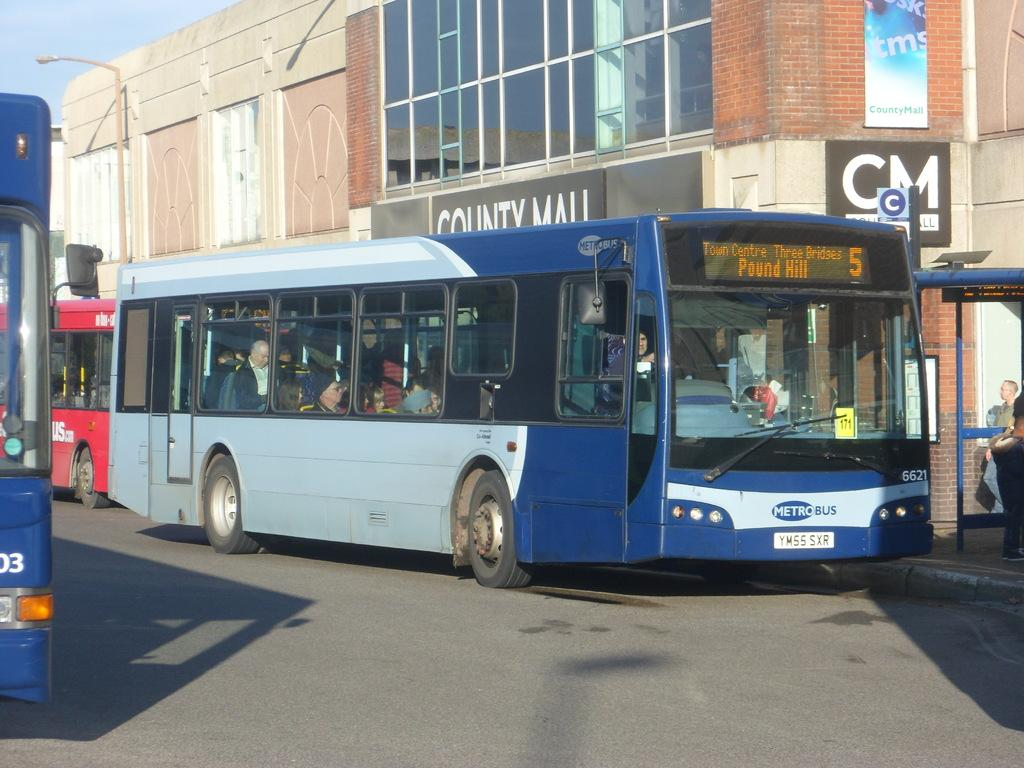<image>
Offer a succinct explanation of the picture presented. Metro Bus number 5 in front of County Mall going on the Pound Hill route. 